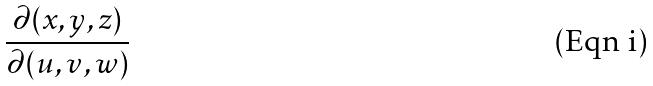<formula> <loc_0><loc_0><loc_500><loc_500>\frac { \partial ( x , y , z ) } { \partial ( u , v , w ) }</formula> 